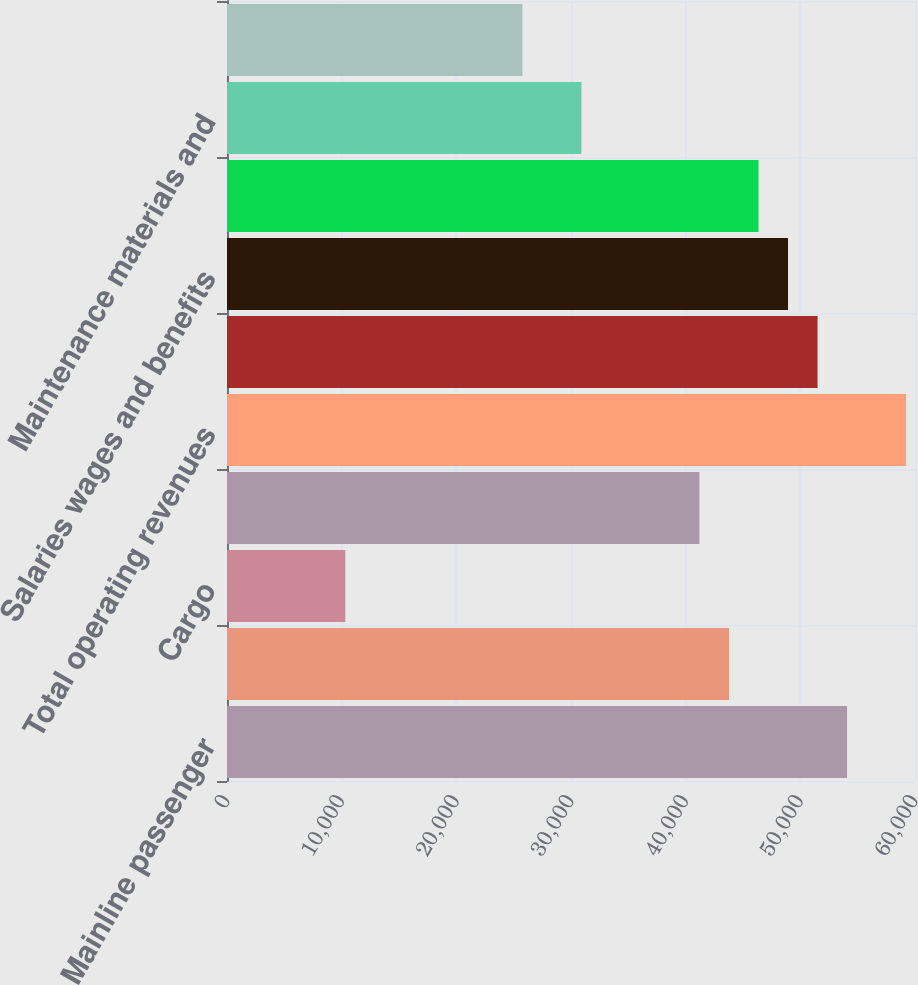Convert chart to OTSL. <chart><loc_0><loc_0><loc_500><loc_500><bar_chart><fcel>Mainline passenger<fcel>Regional passenger<fcel>Cargo<fcel>Other<fcel>Total operating revenues<fcel>Aircraft fuel and related<fcel>Salaries wages and benefits<fcel>Regional expenses<fcel>Maintenance materials and<fcel>Other rent and landing fees<nl><fcel>54074<fcel>43778<fcel>10316<fcel>41204<fcel>59222<fcel>51500<fcel>48926<fcel>46352<fcel>30908<fcel>25760<nl></chart> 